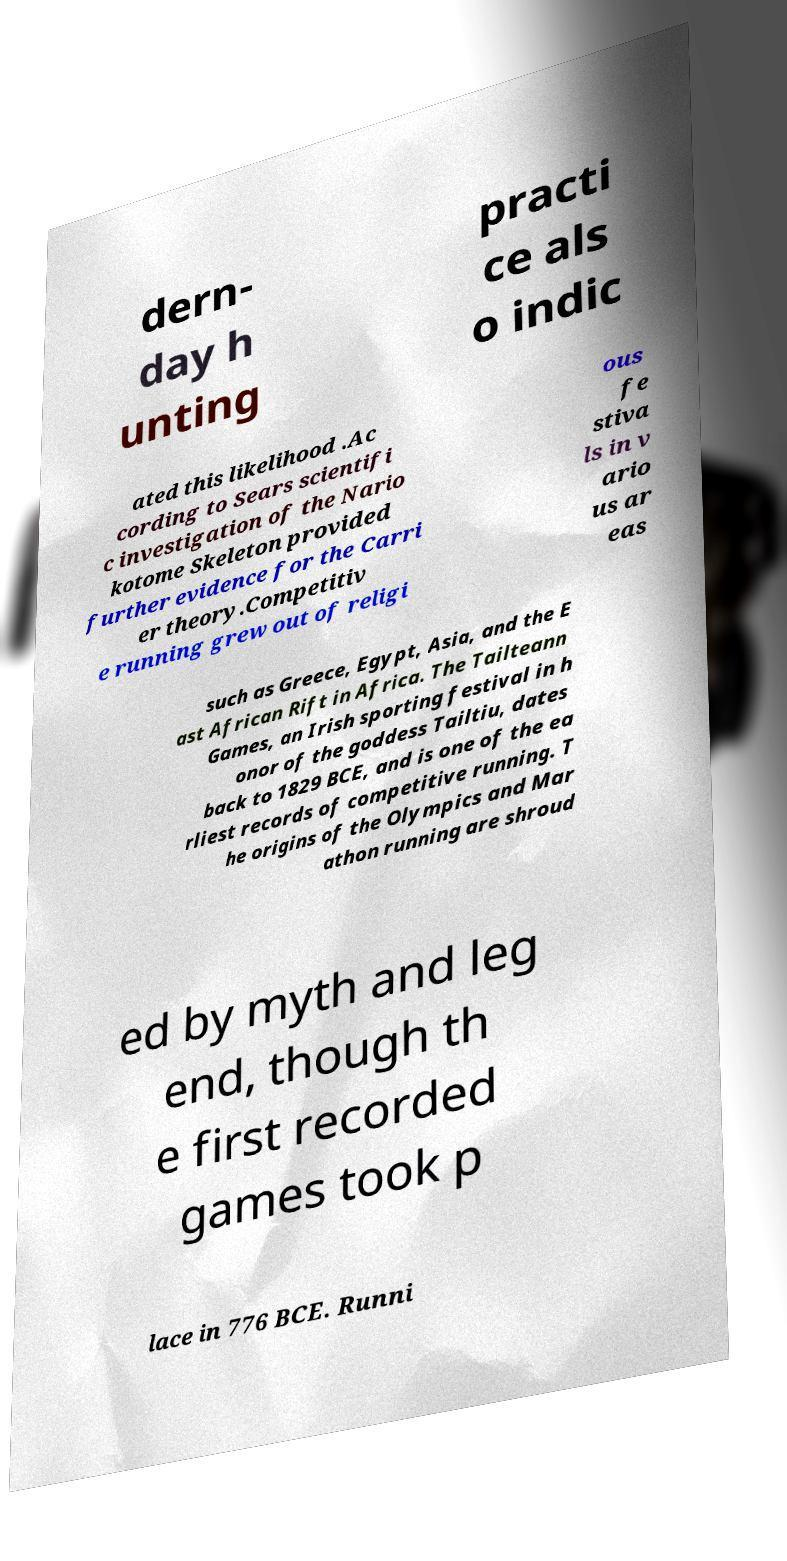Can you accurately transcribe the text from the provided image for me? dern- day h unting practi ce als o indic ated this likelihood .Ac cording to Sears scientifi c investigation of the Nario kotome Skeleton provided further evidence for the Carri er theory.Competitiv e running grew out of religi ous fe stiva ls in v ario us ar eas such as Greece, Egypt, Asia, and the E ast African Rift in Africa. The Tailteann Games, an Irish sporting festival in h onor of the goddess Tailtiu, dates back to 1829 BCE, and is one of the ea rliest records of competitive running. T he origins of the Olympics and Mar athon running are shroud ed by myth and leg end, though th e first recorded games took p lace in 776 BCE. Runni 